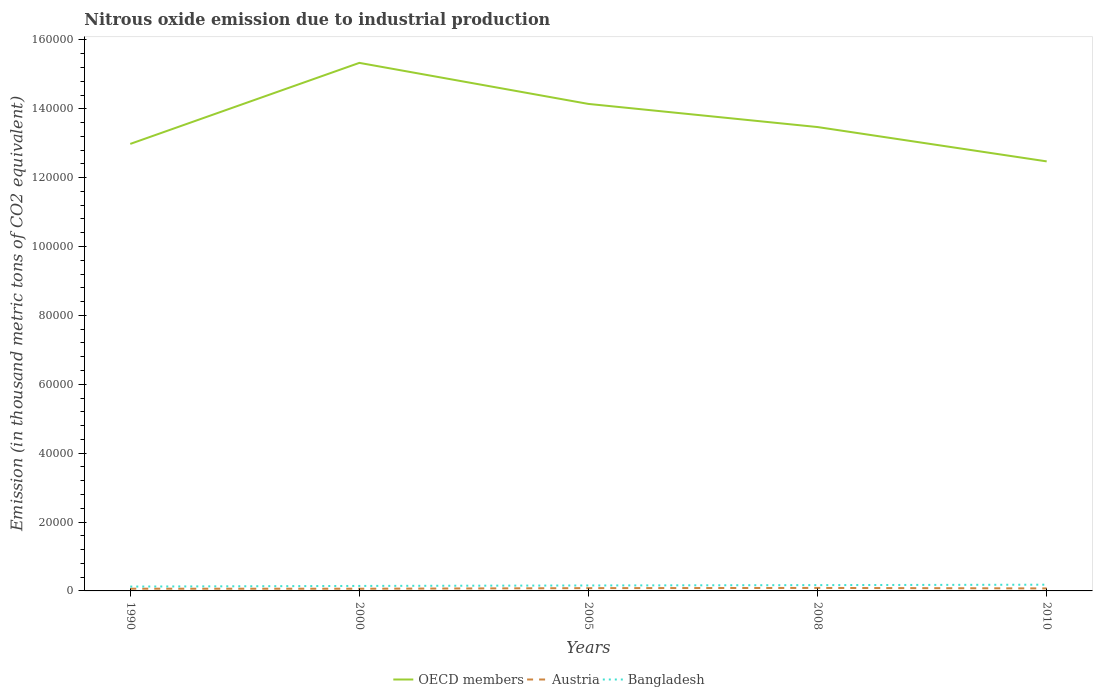How many different coloured lines are there?
Provide a short and direct response. 3. Across all years, what is the maximum amount of nitrous oxide emitted in OECD members?
Give a very brief answer. 1.25e+05. What is the total amount of nitrous oxide emitted in Bangladesh in the graph?
Your answer should be very brief. -421.2. What is the difference between the highest and the second highest amount of nitrous oxide emitted in Austria?
Provide a succinct answer. 230.8. Is the amount of nitrous oxide emitted in OECD members strictly greater than the amount of nitrous oxide emitted in Bangladesh over the years?
Your response must be concise. No. How many years are there in the graph?
Ensure brevity in your answer.  5. Does the graph contain grids?
Your answer should be compact. No. What is the title of the graph?
Your answer should be very brief. Nitrous oxide emission due to industrial production. What is the label or title of the X-axis?
Your response must be concise. Years. What is the label or title of the Y-axis?
Your response must be concise. Emission (in thousand metric tons of CO2 equivalent). What is the Emission (in thousand metric tons of CO2 equivalent) in OECD members in 1990?
Provide a short and direct response. 1.30e+05. What is the Emission (in thousand metric tons of CO2 equivalent) of Austria in 1990?
Your answer should be compact. 642.9. What is the Emission (in thousand metric tons of CO2 equivalent) in Bangladesh in 1990?
Your response must be concise. 1265.7. What is the Emission (in thousand metric tons of CO2 equivalent) of OECD members in 2000?
Ensure brevity in your answer.  1.53e+05. What is the Emission (in thousand metric tons of CO2 equivalent) of Austria in 2000?
Keep it short and to the point. 637.1. What is the Emission (in thousand metric tons of CO2 equivalent) in Bangladesh in 2000?
Ensure brevity in your answer.  1450.3. What is the Emission (in thousand metric tons of CO2 equivalent) of OECD members in 2005?
Offer a terse response. 1.41e+05. What is the Emission (in thousand metric tons of CO2 equivalent) of Austria in 2005?
Offer a very short reply. 808.6. What is the Emission (in thousand metric tons of CO2 equivalent) of Bangladesh in 2005?
Ensure brevity in your answer.  1584.6. What is the Emission (in thousand metric tons of CO2 equivalent) of OECD members in 2008?
Offer a very short reply. 1.35e+05. What is the Emission (in thousand metric tons of CO2 equivalent) in Austria in 2008?
Offer a terse response. 867.9. What is the Emission (in thousand metric tons of CO2 equivalent) in Bangladesh in 2008?
Make the answer very short. 1686.9. What is the Emission (in thousand metric tons of CO2 equivalent) in OECD members in 2010?
Ensure brevity in your answer.  1.25e+05. What is the Emission (in thousand metric tons of CO2 equivalent) of Austria in 2010?
Keep it short and to the point. 728.3. What is the Emission (in thousand metric tons of CO2 equivalent) in Bangladesh in 2010?
Make the answer very short. 1810.8. Across all years, what is the maximum Emission (in thousand metric tons of CO2 equivalent) of OECD members?
Provide a succinct answer. 1.53e+05. Across all years, what is the maximum Emission (in thousand metric tons of CO2 equivalent) in Austria?
Offer a terse response. 867.9. Across all years, what is the maximum Emission (in thousand metric tons of CO2 equivalent) in Bangladesh?
Your response must be concise. 1810.8. Across all years, what is the minimum Emission (in thousand metric tons of CO2 equivalent) in OECD members?
Ensure brevity in your answer.  1.25e+05. Across all years, what is the minimum Emission (in thousand metric tons of CO2 equivalent) in Austria?
Offer a terse response. 637.1. Across all years, what is the minimum Emission (in thousand metric tons of CO2 equivalent) of Bangladesh?
Provide a short and direct response. 1265.7. What is the total Emission (in thousand metric tons of CO2 equivalent) of OECD members in the graph?
Ensure brevity in your answer.  6.84e+05. What is the total Emission (in thousand metric tons of CO2 equivalent) in Austria in the graph?
Ensure brevity in your answer.  3684.8. What is the total Emission (in thousand metric tons of CO2 equivalent) of Bangladesh in the graph?
Ensure brevity in your answer.  7798.3. What is the difference between the Emission (in thousand metric tons of CO2 equivalent) of OECD members in 1990 and that in 2000?
Offer a terse response. -2.35e+04. What is the difference between the Emission (in thousand metric tons of CO2 equivalent) in Austria in 1990 and that in 2000?
Your response must be concise. 5.8. What is the difference between the Emission (in thousand metric tons of CO2 equivalent) in Bangladesh in 1990 and that in 2000?
Ensure brevity in your answer.  -184.6. What is the difference between the Emission (in thousand metric tons of CO2 equivalent) in OECD members in 1990 and that in 2005?
Your response must be concise. -1.16e+04. What is the difference between the Emission (in thousand metric tons of CO2 equivalent) in Austria in 1990 and that in 2005?
Offer a terse response. -165.7. What is the difference between the Emission (in thousand metric tons of CO2 equivalent) in Bangladesh in 1990 and that in 2005?
Your answer should be very brief. -318.9. What is the difference between the Emission (in thousand metric tons of CO2 equivalent) of OECD members in 1990 and that in 2008?
Offer a very short reply. -4894.1. What is the difference between the Emission (in thousand metric tons of CO2 equivalent) of Austria in 1990 and that in 2008?
Give a very brief answer. -225. What is the difference between the Emission (in thousand metric tons of CO2 equivalent) of Bangladesh in 1990 and that in 2008?
Make the answer very short. -421.2. What is the difference between the Emission (in thousand metric tons of CO2 equivalent) in OECD members in 1990 and that in 2010?
Your answer should be compact. 5072.9. What is the difference between the Emission (in thousand metric tons of CO2 equivalent) in Austria in 1990 and that in 2010?
Your answer should be very brief. -85.4. What is the difference between the Emission (in thousand metric tons of CO2 equivalent) of Bangladesh in 1990 and that in 2010?
Your answer should be very brief. -545.1. What is the difference between the Emission (in thousand metric tons of CO2 equivalent) of OECD members in 2000 and that in 2005?
Your answer should be compact. 1.19e+04. What is the difference between the Emission (in thousand metric tons of CO2 equivalent) in Austria in 2000 and that in 2005?
Your answer should be compact. -171.5. What is the difference between the Emission (in thousand metric tons of CO2 equivalent) of Bangladesh in 2000 and that in 2005?
Offer a terse response. -134.3. What is the difference between the Emission (in thousand metric tons of CO2 equivalent) in OECD members in 2000 and that in 2008?
Give a very brief answer. 1.86e+04. What is the difference between the Emission (in thousand metric tons of CO2 equivalent) in Austria in 2000 and that in 2008?
Keep it short and to the point. -230.8. What is the difference between the Emission (in thousand metric tons of CO2 equivalent) of Bangladesh in 2000 and that in 2008?
Make the answer very short. -236.6. What is the difference between the Emission (in thousand metric tons of CO2 equivalent) of OECD members in 2000 and that in 2010?
Your response must be concise. 2.86e+04. What is the difference between the Emission (in thousand metric tons of CO2 equivalent) of Austria in 2000 and that in 2010?
Provide a succinct answer. -91.2. What is the difference between the Emission (in thousand metric tons of CO2 equivalent) in Bangladesh in 2000 and that in 2010?
Make the answer very short. -360.5. What is the difference between the Emission (in thousand metric tons of CO2 equivalent) in OECD members in 2005 and that in 2008?
Offer a terse response. 6713.3. What is the difference between the Emission (in thousand metric tons of CO2 equivalent) of Austria in 2005 and that in 2008?
Make the answer very short. -59.3. What is the difference between the Emission (in thousand metric tons of CO2 equivalent) in Bangladesh in 2005 and that in 2008?
Offer a terse response. -102.3. What is the difference between the Emission (in thousand metric tons of CO2 equivalent) in OECD members in 2005 and that in 2010?
Ensure brevity in your answer.  1.67e+04. What is the difference between the Emission (in thousand metric tons of CO2 equivalent) in Austria in 2005 and that in 2010?
Your response must be concise. 80.3. What is the difference between the Emission (in thousand metric tons of CO2 equivalent) of Bangladesh in 2005 and that in 2010?
Make the answer very short. -226.2. What is the difference between the Emission (in thousand metric tons of CO2 equivalent) in OECD members in 2008 and that in 2010?
Make the answer very short. 9967. What is the difference between the Emission (in thousand metric tons of CO2 equivalent) of Austria in 2008 and that in 2010?
Offer a very short reply. 139.6. What is the difference between the Emission (in thousand metric tons of CO2 equivalent) of Bangladesh in 2008 and that in 2010?
Your answer should be compact. -123.9. What is the difference between the Emission (in thousand metric tons of CO2 equivalent) of OECD members in 1990 and the Emission (in thousand metric tons of CO2 equivalent) of Austria in 2000?
Offer a very short reply. 1.29e+05. What is the difference between the Emission (in thousand metric tons of CO2 equivalent) of OECD members in 1990 and the Emission (in thousand metric tons of CO2 equivalent) of Bangladesh in 2000?
Make the answer very short. 1.28e+05. What is the difference between the Emission (in thousand metric tons of CO2 equivalent) of Austria in 1990 and the Emission (in thousand metric tons of CO2 equivalent) of Bangladesh in 2000?
Your response must be concise. -807.4. What is the difference between the Emission (in thousand metric tons of CO2 equivalent) of OECD members in 1990 and the Emission (in thousand metric tons of CO2 equivalent) of Austria in 2005?
Your answer should be compact. 1.29e+05. What is the difference between the Emission (in thousand metric tons of CO2 equivalent) in OECD members in 1990 and the Emission (in thousand metric tons of CO2 equivalent) in Bangladesh in 2005?
Offer a very short reply. 1.28e+05. What is the difference between the Emission (in thousand metric tons of CO2 equivalent) in Austria in 1990 and the Emission (in thousand metric tons of CO2 equivalent) in Bangladesh in 2005?
Your response must be concise. -941.7. What is the difference between the Emission (in thousand metric tons of CO2 equivalent) of OECD members in 1990 and the Emission (in thousand metric tons of CO2 equivalent) of Austria in 2008?
Provide a short and direct response. 1.29e+05. What is the difference between the Emission (in thousand metric tons of CO2 equivalent) of OECD members in 1990 and the Emission (in thousand metric tons of CO2 equivalent) of Bangladesh in 2008?
Provide a succinct answer. 1.28e+05. What is the difference between the Emission (in thousand metric tons of CO2 equivalent) in Austria in 1990 and the Emission (in thousand metric tons of CO2 equivalent) in Bangladesh in 2008?
Offer a terse response. -1044. What is the difference between the Emission (in thousand metric tons of CO2 equivalent) of OECD members in 1990 and the Emission (in thousand metric tons of CO2 equivalent) of Austria in 2010?
Provide a succinct answer. 1.29e+05. What is the difference between the Emission (in thousand metric tons of CO2 equivalent) of OECD members in 1990 and the Emission (in thousand metric tons of CO2 equivalent) of Bangladesh in 2010?
Your response must be concise. 1.28e+05. What is the difference between the Emission (in thousand metric tons of CO2 equivalent) of Austria in 1990 and the Emission (in thousand metric tons of CO2 equivalent) of Bangladesh in 2010?
Offer a very short reply. -1167.9. What is the difference between the Emission (in thousand metric tons of CO2 equivalent) in OECD members in 2000 and the Emission (in thousand metric tons of CO2 equivalent) in Austria in 2005?
Offer a very short reply. 1.53e+05. What is the difference between the Emission (in thousand metric tons of CO2 equivalent) in OECD members in 2000 and the Emission (in thousand metric tons of CO2 equivalent) in Bangladesh in 2005?
Make the answer very short. 1.52e+05. What is the difference between the Emission (in thousand metric tons of CO2 equivalent) in Austria in 2000 and the Emission (in thousand metric tons of CO2 equivalent) in Bangladesh in 2005?
Offer a terse response. -947.5. What is the difference between the Emission (in thousand metric tons of CO2 equivalent) of OECD members in 2000 and the Emission (in thousand metric tons of CO2 equivalent) of Austria in 2008?
Make the answer very short. 1.52e+05. What is the difference between the Emission (in thousand metric tons of CO2 equivalent) of OECD members in 2000 and the Emission (in thousand metric tons of CO2 equivalent) of Bangladesh in 2008?
Your answer should be very brief. 1.52e+05. What is the difference between the Emission (in thousand metric tons of CO2 equivalent) in Austria in 2000 and the Emission (in thousand metric tons of CO2 equivalent) in Bangladesh in 2008?
Your response must be concise. -1049.8. What is the difference between the Emission (in thousand metric tons of CO2 equivalent) in OECD members in 2000 and the Emission (in thousand metric tons of CO2 equivalent) in Austria in 2010?
Offer a very short reply. 1.53e+05. What is the difference between the Emission (in thousand metric tons of CO2 equivalent) in OECD members in 2000 and the Emission (in thousand metric tons of CO2 equivalent) in Bangladesh in 2010?
Give a very brief answer. 1.52e+05. What is the difference between the Emission (in thousand metric tons of CO2 equivalent) of Austria in 2000 and the Emission (in thousand metric tons of CO2 equivalent) of Bangladesh in 2010?
Provide a succinct answer. -1173.7. What is the difference between the Emission (in thousand metric tons of CO2 equivalent) of OECD members in 2005 and the Emission (in thousand metric tons of CO2 equivalent) of Austria in 2008?
Give a very brief answer. 1.41e+05. What is the difference between the Emission (in thousand metric tons of CO2 equivalent) of OECD members in 2005 and the Emission (in thousand metric tons of CO2 equivalent) of Bangladesh in 2008?
Offer a terse response. 1.40e+05. What is the difference between the Emission (in thousand metric tons of CO2 equivalent) in Austria in 2005 and the Emission (in thousand metric tons of CO2 equivalent) in Bangladesh in 2008?
Keep it short and to the point. -878.3. What is the difference between the Emission (in thousand metric tons of CO2 equivalent) of OECD members in 2005 and the Emission (in thousand metric tons of CO2 equivalent) of Austria in 2010?
Your answer should be very brief. 1.41e+05. What is the difference between the Emission (in thousand metric tons of CO2 equivalent) of OECD members in 2005 and the Emission (in thousand metric tons of CO2 equivalent) of Bangladesh in 2010?
Your response must be concise. 1.40e+05. What is the difference between the Emission (in thousand metric tons of CO2 equivalent) in Austria in 2005 and the Emission (in thousand metric tons of CO2 equivalent) in Bangladesh in 2010?
Provide a short and direct response. -1002.2. What is the difference between the Emission (in thousand metric tons of CO2 equivalent) of OECD members in 2008 and the Emission (in thousand metric tons of CO2 equivalent) of Austria in 2010?
Offer a terse response. 1.34e+05. What is the difference between the Emission (in thousand metric tons of CO2 equivalent) in OECD members in 2008 and the Emission (in thousand metric tons of CO2 equivalent) in Bangladesh in 2010?
Provide a succinct answer. 1.33e+05. What is the difference between the Emission (in thousand metric tons of CO2 equivalent) of Austria in 2008 and the Emission (in thousand metric tons of CO2 equivalent) of Bangladesh in 2010?
Your answer should be very brief. -942.9. What is the average Emission (in thousand metric tons of CO2 equivalent) in OECD members per year?
Provide a succinct answer. 1.37e+05. What is the average Emission (in thousand metric tons of CO2 equivalent) in Austria per year?
Make the answer very short. 736.96. What is the average Emission (in thousand metric tons of CO2 equivalent) of Bangladesh per year?
Provide a succinct answer. 1559.66. In the year 1990, what is the difference between the Emission (in thousand metric tons of CO2 equivalent) of OECD members and Emission (in thousand metric tons of CO2 equivalent) of Austria?
Provide a short and direct response. 1.29e+05. In the year 1990, what is the difference between the Emission (in thousand metric tons of CO2 equivalent) in OECD members and Emission (in thousand metric tons of CO2 equivalent) in Bangladesh?
Your response must be concise. 1.29e+05. In the year 1990, what is the difference between the Emission (in thousand metric tons of CO2 equivalent) in Austria and Emission (in thousand metric tons of CO2 equivalent) in Bangladesh?
Make the answer very short. -622.8. In the year 2000, what is the difference between the Emission (in thousand metric tons of CO2 equivalent) of OECD members and Emission (in thousand metric tons of CO2 equivalent) of Austria?
Offer a terse response. 1.53e+05. In the year 2000, what is the difference between the Emission (in thousand metric tons of CO2 equivalent) in OECD members and Emission (in thousand metric tons of CO2 equivalent) in Bangladesh?
Give a very brief answer. 1.52e+05. In the year 2000, what is the difference between the Emission (in thousand metric tons of CO2 equivalent) of Austria and Emission (in thousand metric tons of CO2 equivalent) of Bangladesh?
Keep it short and to the point. -813.2. In the year 2005, what is the difference between the Emission (in thousand metric tons of CO2 equivalent) of OECD members and Emission (in thousand metric tons of CO2 equivalent) of Austria?
Give a very brief answer. 1.41e+05. In the year 2005, what is the difference between the Emission (in thousand metric tons of CO2 equivalent) of OECD members and Emission (in thousand metric tons of CO2 equivalent) of Bangladesh?
Make the answer very short. 1.40e+05. In the year 2005, what is the difference between the Emission (in thousand metric tons of CO2 equivalent) in Austria and Emission (in thousand metric tons of CO2 equivalent) in Bangladesh?
Offer a terse response. -776. In the year 2008, what is the difference between the Emission (in thousand metric tons of CO2 equivalent) of OECD members and Emission (in thousand metric tons of CO2 equivalent) of Austria?
Give a very brief answer. 1.34e+05. In the year 2008, what is the difference between the Emission (in thousand metric tons of CO2 equivalent) of OECD members and Emission (in thousand metric tons of CO2 equivalent) of Bangladesh?
Give a very brief answer. 1.33e+05. In the year 2008, what is the difference between the Emission (in thousand metric tons of CO2 equivalent) of Austria and Emission (in thousand metric tons of CO2 equivalent) of Bangladesh?
Ensure brevity in your answer.  -819. In the year 2010, what is the difference between the Emission (in thousand metric tons of CO2 equivalent) of OECD members and Emission (in thousand metric tons of CO2 equivalent) of Austria?
Offer a very short reply. 1.24e+05. In the year 2010, what is the difference between the Emission (in thousand metric tons of CO2 equivalent) in OECD members and Emission (in thousand metric tons of CO2 equivalent) in Bangladesh?
Your answer should be very brief. 1.23e+05. In the year 2010, what is the difference between the Emission (in thousand metric tons of CO2 equivalent) in Austria and Emission (in thousand metric tons of CO2 equivalent) in Bangladesh?
Keep it short and to the point. -1082.5. What is the ratio of the Emission (in thousand metric tons of CO2 equivalent) in OECD members in 1990 to that in 2000?
Offer a very short reply. 0.85. What is the ratio of the Emission (in thousand metric tons of CO2 equivalent) in Austria in 1990 to that in 2000?
Your response must be concise. 1.01. What is the ratio of the Emission (in thousand metric tons of CO2 equivalent) in Bangladesh in 1990 to that in 2000?
Ensure brevity in your answer.  0.87. What is the ratio of the Emission (in thousand metric tons of CO2 equivalent) in OECD members in 1990 to that in 2005?
Give a very brief answer. 0.92. What is the ratio of the Emission (in thousand metric tons of CO2 equivalent) in Austria in 1990 to that in 2005?
Keep it short and to the point. 0.8. What is the ratio of the Emission (in thousand metric tons of CO2 equivalent) in Bangladesh in 1990 to that in 2005?
Offer a terse response. 0.8. What is the ratio of the Emission (in thousand metric tons of CO2 equivalent) in OECD members in 1990 to that in 2008?
Make the answer very short. 0.96. What is the ratio of the Emission (in thousand metric tons of CO2 equivalent) of Austria in 1990 to that in 2008?
Make the answer very short. 0.74. What is the ratio of the Emission (in thousand metric tons of CO2 equivalent) in Bangladesh in 1990 to that in 2008?
Provide a short and direct response. 0.75. What is the ratio of the Emission (in thousand metric tons of CO2 equivalent) in OECD members in 1990 to that in 2010?
Ensure brevity in your answer.  1.04. What is the ratio of the Emission (in thousand metric tons of CO2 equivalent) of Austria in 1990 to that in 2010?
Ensure brevity in your answer.  0.88. What is the ratio of the Emission (in thousand metric tons of CO2 equivalent) of Bangladesh in 1990 to that in 2010?
Ensure brevity in your answer.  0.7. What is the ratio of the Emission (in thousand metric tons of CO2 equivalent) of OECD members in 2000 to that in 2005?
Provide a succinct answer. 1.08. What is the ratio of the Emission (in thousand metric tons of CO2 equivalent) of Austria in 2000 to that in 2005?
Offer a terse response. 0.79. What is the ratio of the Emission (in thousand metric tons of CO2 equivalent) in Bangladesh in 2000 to that in 2005?
Give a very brief answer. 0.92. What is the ratio of the Emission (in thousand metric tons of CO2 equivalent) in OECD members in 2000 to that in 2008?
Give a very brief answer. 1.14. What is the ratio of the Emission (in thousand metric tons of CO2 equivalent) in Austria in 2000 to that in 2008?
Make the answer very short. 0.73. What is the ratio of the Emission (in thousand metric tons of CO2 equivalent) in Bangladesh in 2000 to that in 2008?
Your response must be concise. 0.86. What is the ratio of the Emission (in thousand metric tons of CO2 equivalent) in OECD members in 2000 to that in 2010?
Offer a terse response. 1.23. What is the ratio of the Emission (in thousand metric tons of CO2 equivalent) of Austria in 2000 to that in 2010?
Offer a very short reply. 0.87. What is the ratio of the Emission (in thousand metric tons of CO2 equivalent) of Bangladesh in 2000 to that in 2010?
Make the answer very short. 0.8. What is the ratio of the Emission (in thousand metric tons of CO2 equivalent) of OECD members in 2005 to that in 2008?
Provide a short and direct response. 1.05. What is the ratio of the Emission (in thousand metric tons of CO2 equivalent) in Austria in 2005 to that in 2008?
Make the answer very short. 0.93. What is the ratio of the Emission (in thousand metric tons of CO2 equivalent) in Bangladesh in 2005 to that in 2008?
Offer a terse response. 0.94. What is the ratio of the Emission (in thousand metric tons of CO2 equivalent) in OECD members in 2005 to that in 2010?
Ensure brevity in your answer.  1.13. What is the ratio of the Emission (in thousand metric tons of CO2 equivalent) in Austria in 2005 to that in 2010?
Offer a terse response. 1.11. What is the ratio of the Emission (in thousand metric tons of CO2 equivalent) of Bangladesh in 2005 to that in 2010?
Keep it short and to the point. 0.88. What is the ratio of the Emission (in thousand metric tons of CO2 equivalent) in OECD members in 2008 to that in 2010?
Offer a terse response. 1.08. What is the ratio of the Emission (in thousand metric tons of CO2 equivalent) in Austria in 2008 to that in 2010?
Provide a short and direct response. 1.19. What is the ratio of the Emission (in thousand metric tons of CO2 equivalent) in Bangladesh in 2008 to that in 2010?
Offer a very short reply. 0.93. What is the difference between the highest and the second highest Emission (in thousand metric tons of CO2 equivalent) in OECD members?
Offer a very short reply. 1.19e+04. What is the difference between the highest and the second highest Emission (in thousand metric tons of CO2 equivalent) of Austria?
Your answer should be very brief. 59.3. What is the difference between the highest and the second highest Emission (in thousand metric tons of CO2 equivalent) in Bangladesh?
Give a very brief answer. 123.9. What is the difference between the highest and the lowest Emission (in thousand metric tons of CO2 equivalent) in OECD members?
Give a very brief answer. 2.86e+04. What is the difference between the highest and the lowest Emission (in thousand metric tons of CO2 equivalent) of Austria?
Provide a short and direct response. 230.8. What is the difference between the highest and the lowest Emission (in thousand metric tons of CO2 equivalent) in Bangladesh?
Offer a terse response. 545.1. 